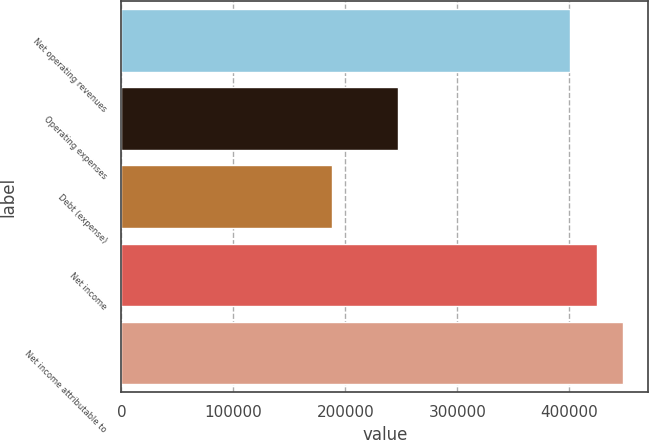Convert chart to OTSL. <chart><loc_0><loc_0><loc_500><loc_500><bar_chart><fcel>Net operating revenues<fcel>Operating expenses<fcel>Debt (expense)<fcel>Net income<fcel>Net income attributable to<nl><fcel>401058<fcel>246578<fcel>188109<fcel>424516<fcel>447973<nl></chart> 